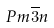<formula> <loc_0><loc_0><loc_500><loc_500>P m \overline { 3 } n</formula> 